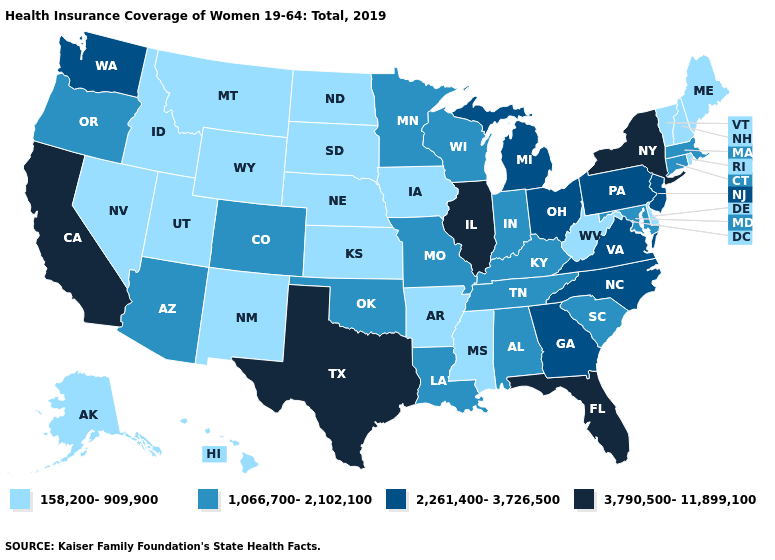Does Kansas have a lower value than Oklahoma?
Keep it brief. Yes. Name the states that have a value in the range 2,261,400-3,726,500?
Keep it brief. Georgia, Michigan, New Jersey, North Carolina, Ohio, Pennsylvania, Virginia, Washington. Name the states that have a value in the range 1,066,700-2,102,100?
Answer briefly. Alabama, Arizona, Colorado, Connecticut, Indiana, Kentucky, Louisiana, Maryland, Massachusetts, Minnesota, Missouri, Oklahoma, Oregon, South Carolina, Tennessee, Wisconsin. Name the states that have a value in the range 1,066,700-2,102,100?
Answer briefly. Alabama, Arizona, Colorado, Connecticut, Indiana, Kentucky, Louisiana, Maryland, Massachusetts, Minnesota, Missouri, Oklahoma, Oregon, South Carolina, Tennessee, Wisconsin. How many symbols are there in the legend?
Keep it brief. 4. Name the states that have a value in the range 2,261,400-3,726,500?
Give a very brief answer. Georgia, Michigan, New Jersey, North Carolina, Ohio, Pennsylvania, Virginia, Washington. Does Indiana have the same value as Ohio?
Concise answer only. No. Does Kentucky have a higher value than Nevada?
Be succinct. Yes. What is the value of Virginia?
Write a very short answer. 2,261,400-3,726,500. Does the map have missing data?
Quick response, please. No. Does the map have missing data?
Give a very brief answer. No. What is the value of Colorado?
Keep it brief. 1,066,700-2,102,100. What is the lowest value in the West?
Give a very brief answer. 158,200-909,900. What is the value of Illinois?
Short answer required. 3,790,500-11,899,100. Among the states that border Texas , which have the lowest value?
Give a very brief answer. Arkansas, New Mexico. 